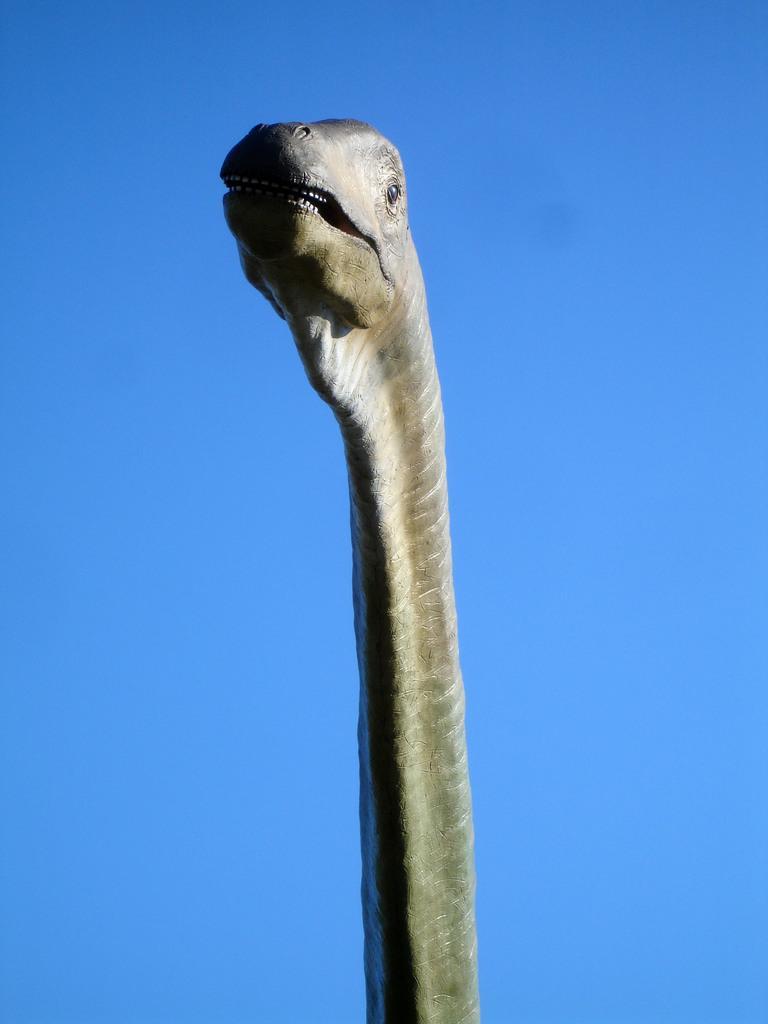Describe this image in one or two sentences. In this image we can see an animal head and the sky. 